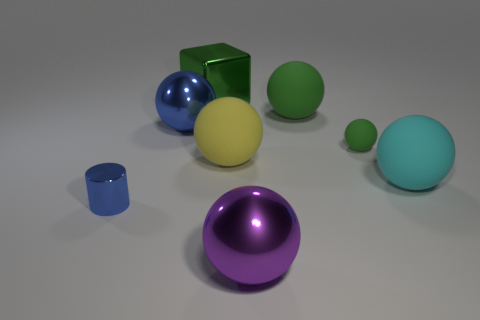Subtract all yellow blocks. How many green balls are left? 2 Subtract all large blue spheres. How many spheres are left? 5 Add 1 big cyan rubber things. How many objects exist? 9 Subtract all blue spheres. How many spheres are left? 5 Subtract 3 balls. How many balls are left? 3 Subtract all spheres. How many objects are left? 2 Subtract all purple balls. Subtract all brown cylinders. How many balls are left? 5 Add 7 big purple metallic things. How many big purple metallic things exist? 8 Subtract 0 brown cylinders. How many objects are left? 8 Subtract all small matte things. Subtract all gray metallic blocks. How many objects are left? 7 